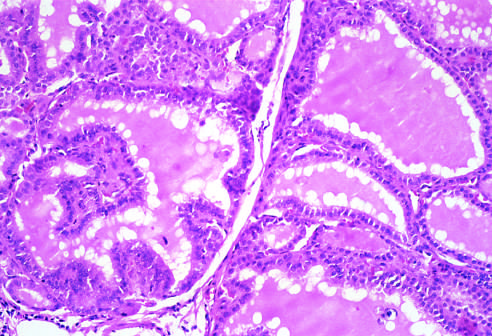what are lined by tall columnar epithelial cells that are actively resorbing the colloid in the centers of the follicles, resulting in a scalloped appearance of the colloid?
Answer the question using a single word or phrase. The follicles 